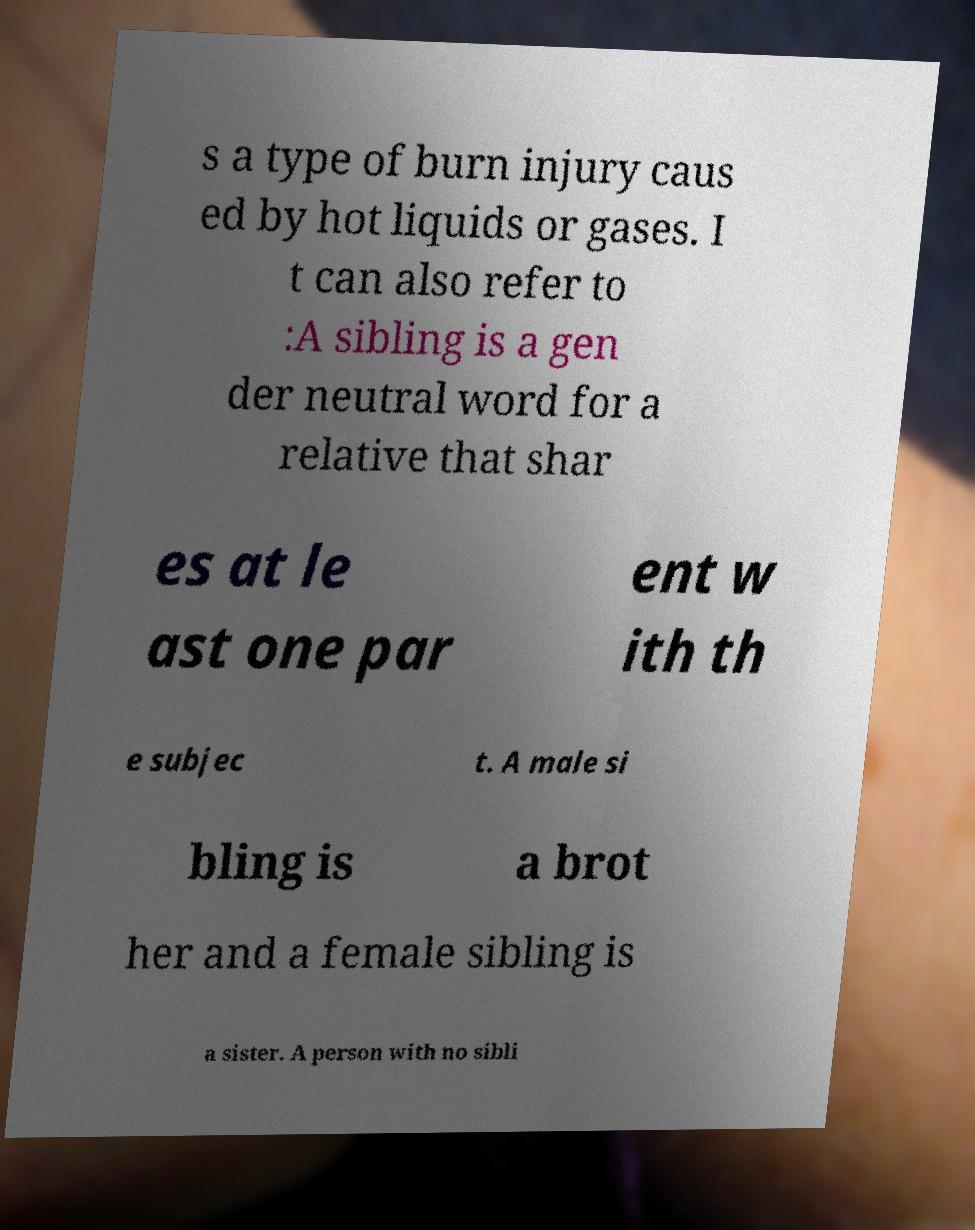For documentation purposes, I need the text within this image transcribed. Could you provide that? s a type of burn injury caus ed by hot liquids or gases. I t can also refer to :A sibling is a gen der neutral word for a relative that shar es at le ast one par ent w ith th e subjec t. A male si bling is a brot her and a female sibling is a sister. A person with no sibli 